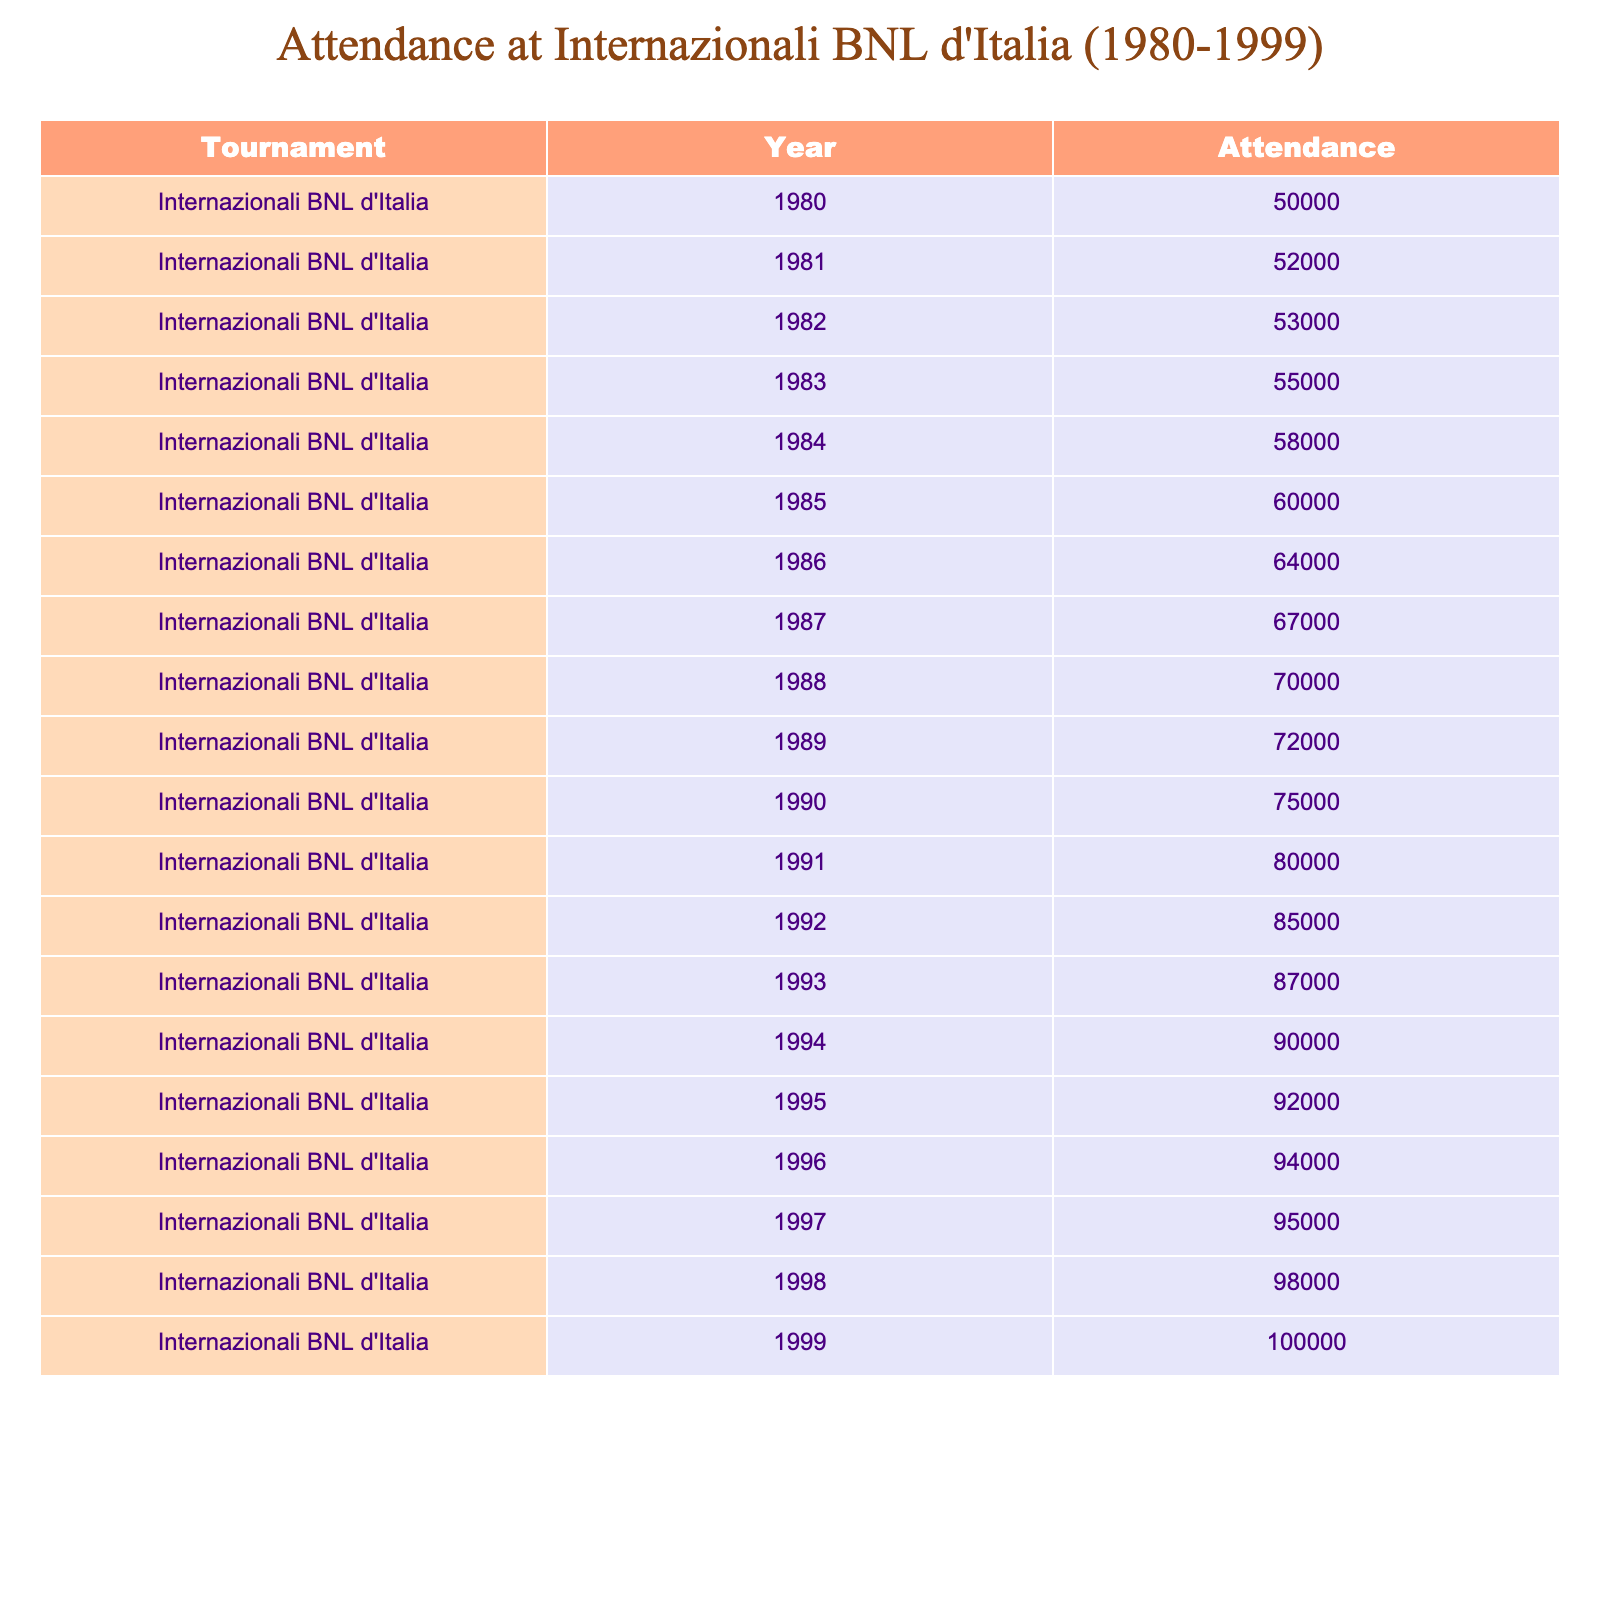What was the highest attendance figure recorded at the Internazionali BNL d'Italia? The highest attendance figure of 100,000 was recorded in the year 1999. This value can be found in the "Attendance" column for the year specified.
Answer: 100,000 In which year did the attendance surpass 80,000 for the first time? The attendance first surpassed 80,000 in the year 1991, where the attendance was 80,000. By checking the attendance figures for each year, we can see that this is the first instance that meets the criteria.
Answer: 1991 What was the average attendance over the entire period from 1980 to 1999? To find the average attendance, we first sum all the attendance figures (50000 + 52000 + ... + 100000) which equals 1,570,000. Then, we divide this sum by the number of years, which is 20, resulting in an average of 78,500.
Answer: 78,500 Did the attendance increase every year from 1980 to 1999? Yes, the attendance figures show a consistent increase every year from 1980 to 1999, as shown by the attendance values in the table being strictly higher in each subsequent year.
Answer: Yes What was the total increase in attendance from 1980 to 1999? The total increase can be found by subtracting the attendance figure of 1980 from that of 1999. Therefore, 100,000 (1999) - 50,000 (1980) = 50,000. This is a straightforward subtraction of the two figures from the table.
Answer: 50,000 In which year did the attendance reach 90000 for the first time? The attendance first reached 90,000 in the year 1994. This can be seen by checking the attendance figures until we identify the first occurrence of 90,000 in the data.
Answer: 1994 How many years did the attendance remain below 70,000? The attendance remained below 70,000 for the first nine years (from 1980 to 1988), with 1989 being the first year to exceed that threshold at 72,000. By counting the years with figures under 70,000, we can confirm the total.
Answer: 9 years What was the difference in attendance from 1990 to 1999? The difference in attendance between 1990 (75,000) and 1999 (100,000) is 100,000 - 75,000 = 25,000. Here, the subtraction reveals the increase of attendance over that nine-year span.
Answer: 25,000 What was the attendance figure in 1986 compared to 1988? The attendance in 1986 was 64,000 and in 1988 it was 70,000. The difference here is 70,000 - 64,000 = 6,000, meaning 1988 had 6,000 more attendees than 1986.
Answer: 6,000 